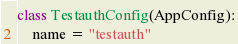Convert code to text. <code><loc_0><loc_0><loc_500><loc_500><_Python_>

class TestauthConfig(AppConfig):
    name = "testauth"
</code> 